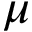<formula> <loc_0><loc_0><loc_500><loc_500>\mu</formula> 